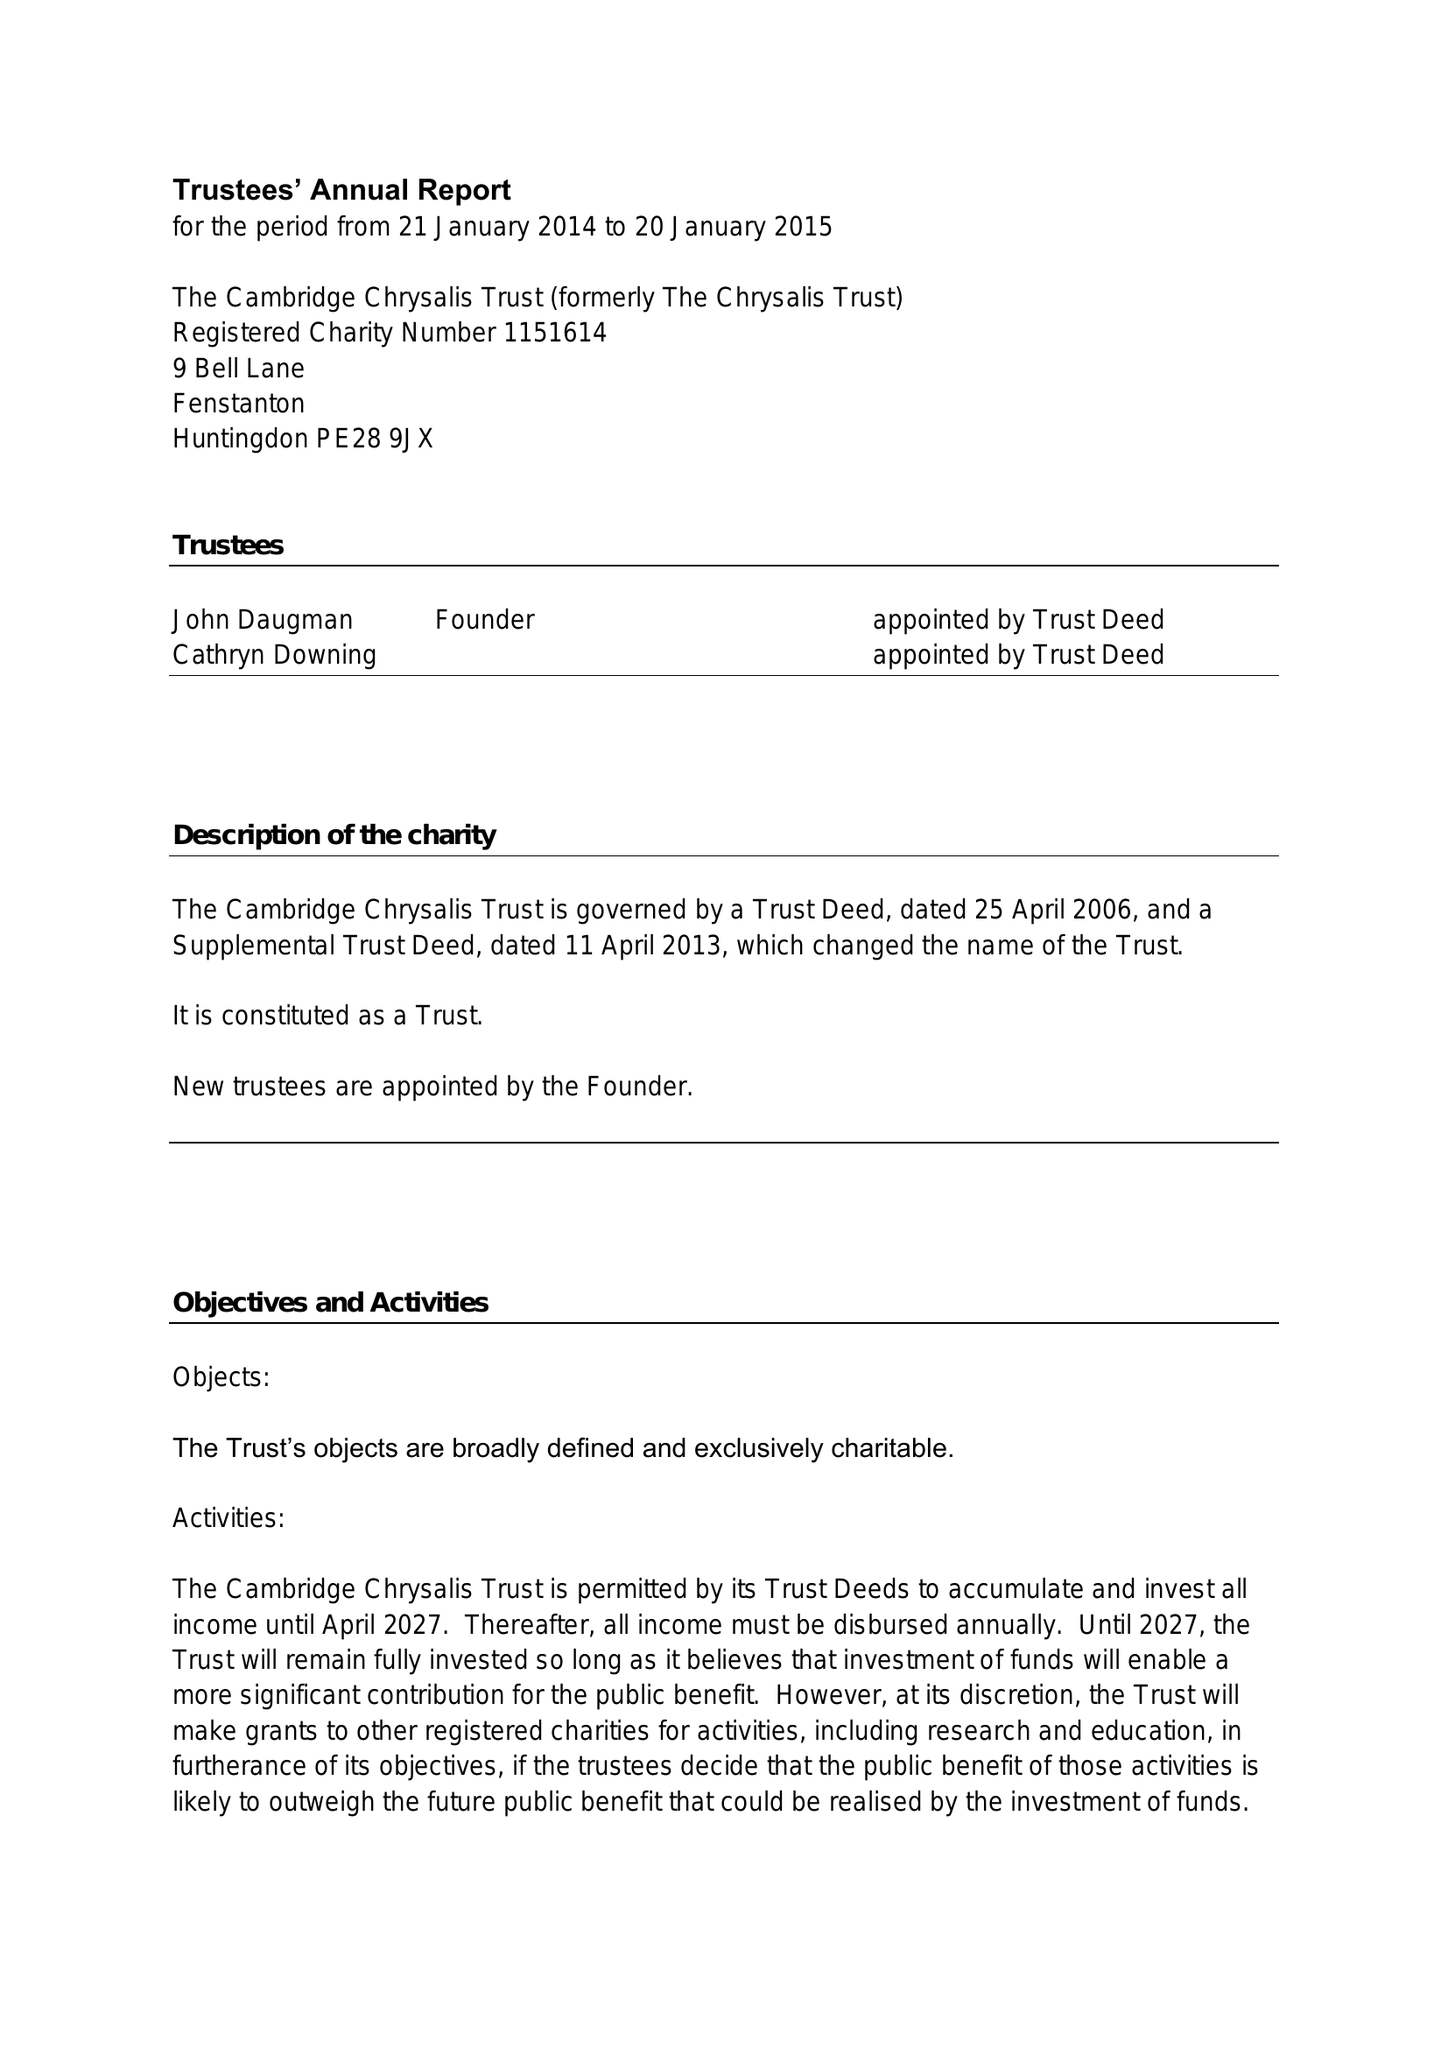What is the value for the address__postcode?
Answer the question using a single word or phrase. PE28 9JX 